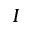<formula> <loc_0><loc_0><loc_500><loc_500>I</formula> 